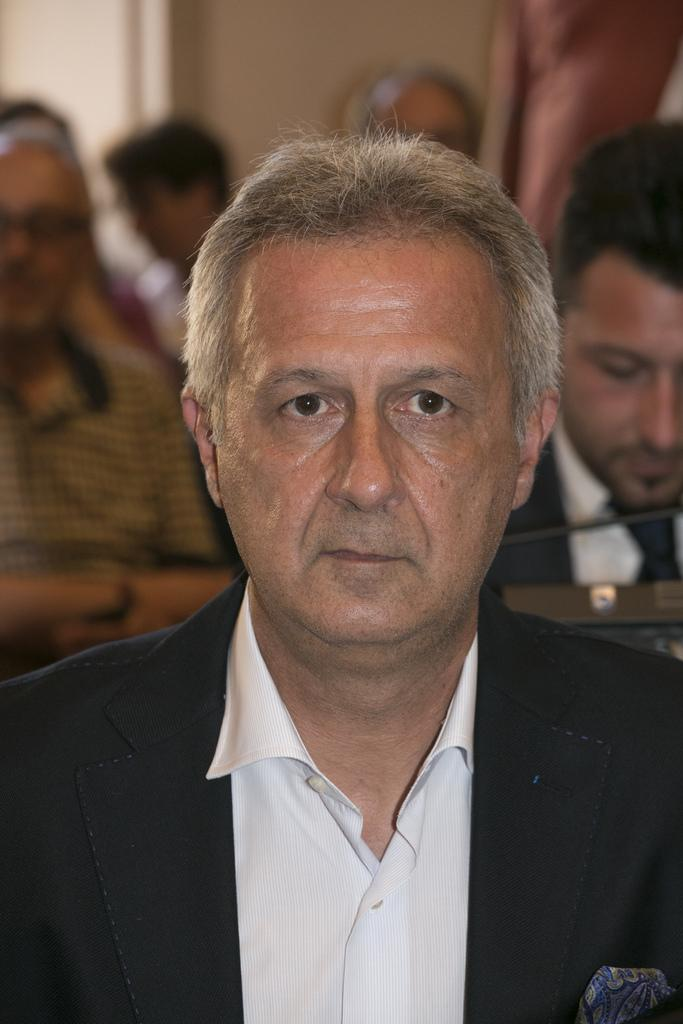How many people are in the image? There are persons in the image. What are the persons wearing? The persons are wearing clothes. Can you describe the background of the image? The background of the image is blurred. What is the relationship between the persons and their brother in the image? There is no mention of a brother in the image, so we cannot determine any relationship between the persons and a brother. 